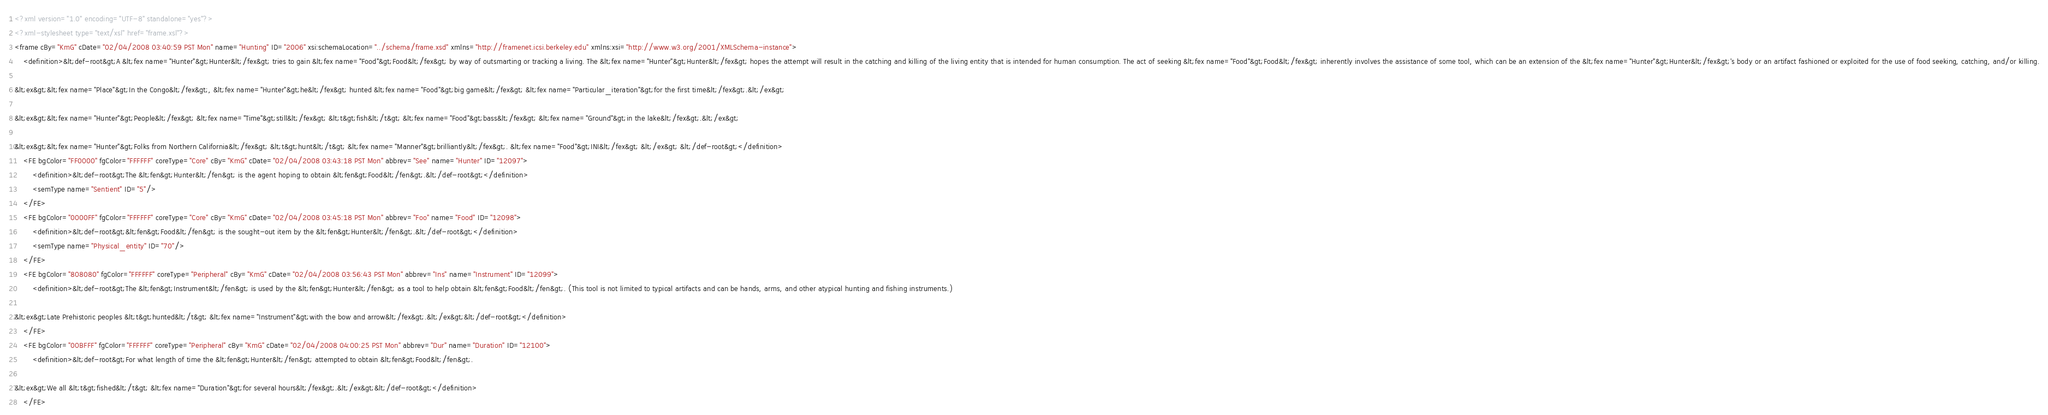<code> <loc_0><loc_0><loc_500><loc_500><_XML_><?xml version="1.0" encoding="UTF-8" standalone="yes"?>
<?xml-stylesheet type="text/xsl" href="frame.xsl"?>
<frame cBy="KmG" cDate="02/04/2008 03:40:59 PST Mon" name="Hunting" ID="2006" xsi:schemaLocation="../schema/frame.xsd" xmlns="http://framenet.icsi.berkeley.edu" xmlns:xsi="http://www.w3.org/2001/XMLSchema-instance">
    <definition>&lt;def-root&gt;A &lt;fex name="Hunter"&gt;Hunter&lt;/fex&gt; tries to gain &lt;fex name="Food"&gt;Food&lt;/fex&gt; by way of outsmarting or tracking a living. The &lt;fex name="Hunter"&gt;Hunter&lt;/fex&gt; hopes the attempt will result in the catching and killing of the living entity that is intended for human consumption. The act of seeking &lt;fex name="Food"&gt;Food&lt;/fex&gt; inherently involves the assistance of some tool, which can be an extension of the &lt;fex name="Hunter"&gt;Hunter&lt;/fex&gt;'s body or an artifact fashioned or exploited for the use of food seeking, catching, and/or killing.

&lt;ex&gt;&lt;fex name="Place"&gt;In the Congo&lt;/fex&gt;, &lt;fex name="Hunter"&gt;he&lt;/fex&gt; hunted &lt;fex name="Food"&gt;big game&lt;/fex&gt; &lt;fex name="Particular_iteration"&gt;for the first time&lt;/fex&gt;.&lt;/ex&gt;

&lt;ex&gt;&lt;fex name="Hunter"&gt;People&lt;/fex&gt; &lt;fex name="Time"&gt;still&lt;/fex&gt; &lt;t&gt;fish&lt;/t&gt; &lt;fex name="Food"&gt;bass&lt;/fex&gt; &lt;fex name="Ground"&gt;in the lake&lt;/fex&gt;.&lt;/ex&gt;

&lt;ex&gt;&lt;fex name="Hunter"&gt;Folks from Northern California&lt;/fex&gt; &lt;t&gt;hunt&lt;/t&gt; &lt;fex name="Manner"&gt;brilliantly&lt;/fex&gt;. &lt;fex name="Food"&gt;INI&lt;/fex&gt; &lt;/ex&gt; &lt;/def-root&gt;</definition>
    <FE bgColor="FF0000" fgColor="FFFFFF" coreType="Core" cBy="KmG" cDate="02/04/2008 03:43:18 PST Mon" abbrev="See" name="Hunter" ID="12097">
        <definition>&lt;def-root&gt;The &lt;fen&gt;Hunter&lt;/fen&gt; is the agent hoping to obtain &lt;fen&gt;Food&lt;/fen&gt;.&lt;/def-root&gt;</definition>
        <semType name="Sentient" ID="5"/>
    </FE>
    <FE bgColor="0000FF" fgColor="FFFFFF" coreType="Core" cBy="KmG" cDate="02/04/2008 03:45:18 PST Mon" abbrev="Foo" name="Food" ID="12098">
        <definition>&lt;def-root&gt;&lt;fen&gt;Food&lt;/fen&gt; is the sought-out item by the &lt;fen&gt;Hunter&lt;/fen&gt;.&lt;/def-root&gt;</definition>
        <semType name="Physical_entity" ID="70"/>
    </FE>
    <FE bgColor="808080" fgColor="FFFFFF" coreType="Peripheral" cBy="KmG" cDate="02/04/2008 03:56:43 PST Mon" abbrev="Ins" name="Instrument" ID="12099">
        <definition>&lt;def-root&gt;The &lt;fen&gt;Instrument&lt;/fen&gt; is used by the &lt;fen&gt;Hunter&lt;/fen&gt; as a tool to help obtain &lt;fen&gt;Food&lt;/fen&gt;. (This tool is not limited to typical artifacts and can be hands, arms, and other atypical hunting and fishing instruments.)

&lt;ex&gt;Late Prehistoric peoples &lt;t&gt;hunted&lt;/t&gt; &lt;fex name="Instrument"&gt;with the bow and arrow&lt;/fex&gt;.&lt;/ex&gt;&lt;/def-root&gt;</definition>
    </FE>
    <FE bgColor="00BFFF" fgColor="FFFFFF" coreType="Peripheral" cBy="KmG" cDate="02/04/2008 04:00:25 PST Mon" abbrev="Dur" name="Duration" ID="12100">
        <definition>&lt;def-root&gt;For what length of time the &lt;fen&gt;Hunter&lt;/fen&gt; attempted to obtain &lt;fen&gt;Food&lt;/fen&gt;. 

&lt;ex&gt;We all &lt;t&gt;fished&lt;/t&gt; &lt;fex name="Duration"&gt;for several hours&lt;/fex&gt;.&lt;/ex&gt;&lt;/def-root&gt;</definition>
    </FE></code> 